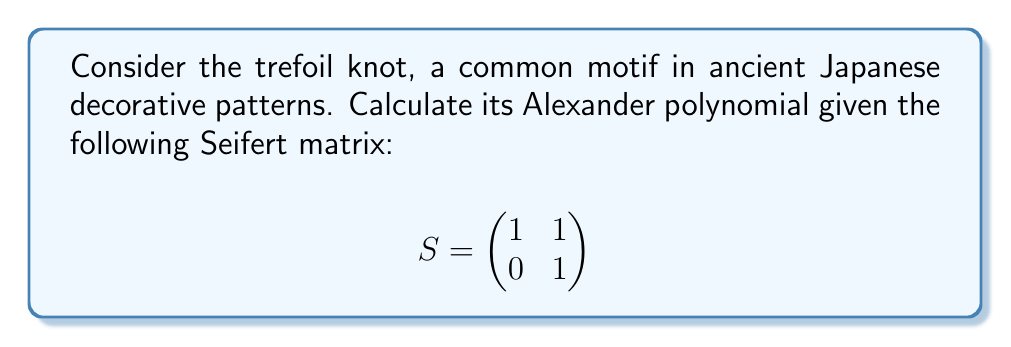Show me your answer to this math problem. To determine the Alexander polynomial of the trefoil knot, we'll follow these steps:

1. Given the Seifert matrix $S$, we need to compute $tS - S^T$.

$$tS - S^T = t\begin{pmatrix}
1 & 1 \\
0 & 1
\end{pmatrix} - \begin{pmatrix}
1 & 0 \\
1 & 1
\end{pmatrix}$$

2. Simplify the matrix:

$$tS - S^T = \begin{pmatrix}
t-1 & t \\
-1 & t-1
\end{pmatrix}$$

3. The Alexander polynomial $\Delta(t)$ is the determinant of this matrix:

$$\Delta(t) = \det(tS - S^T) = \det\begin{pmatrix}
t-1 & t \\
-1 & t-1
\end{pmatrix}$$

4. Calculate the determinant:

$$\Delta(t) = (t-1)(t-1) - (-1)(t)$$
$$\Delta(t) = t^2 - 2t + 1 + t$$
$$\Delta(t) = t^2 - t + 1$$

5. Normalize the polynomial by multiplying by $\pm t^k$ to make the lowest degree term positive and the highest degree coefficient positive:

$$\Delta(t) = t^2 - t + 1$$

This is already in the correct form, so no further normalization is needed.
Answer: $\Delta(t) = t^2 - t + 1$ 